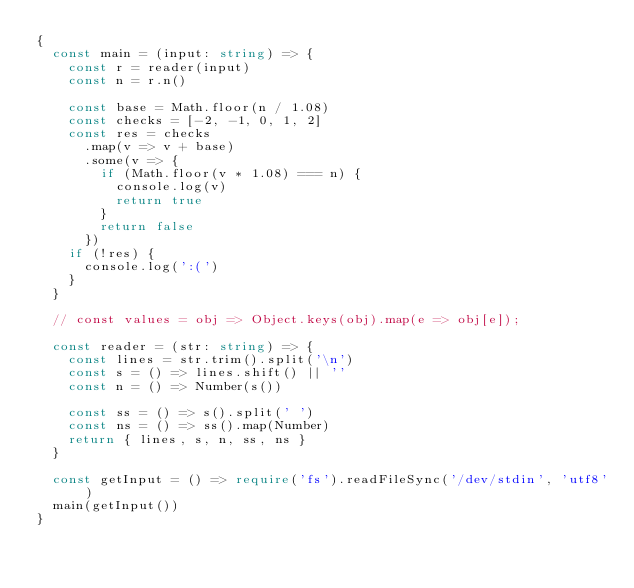Convert code to text. <code><loc_0><loc_0><loc_500><loc_500><_TypeScript_>{
  const main = (input: string) => {
    const r = reader(input)
    const n = r.n()

    const base = Math.floor(n / 1.08)
    const checks = [-2, -1, 0, 1, 2]
    const res = checks
      .map(v => v + base)
      .some(v => {
        if (Math.floor(v * 1.08) === n) {
          console.log(v)
          return true
        }
        return false
      })
    if (!res) {
      console.log(':(')
    }
  }

  // const values = obj => Object.keys(obj).map(e => obj[e]);

  const reader = (str: string) => {
    const lines = str.trim().split('\n')
    const s = () => lines.shift() || ''
    const n = () => Number(s())

    const ss = () => s().split(' ')
    const ns = () => ss().map(Number)
    return { lines, s, n, ss, ns }
  }

  const getInput = () => require('fs').readFileSync('/dev/stdin', 'utf8')
  main(getInput())
}
</code> 